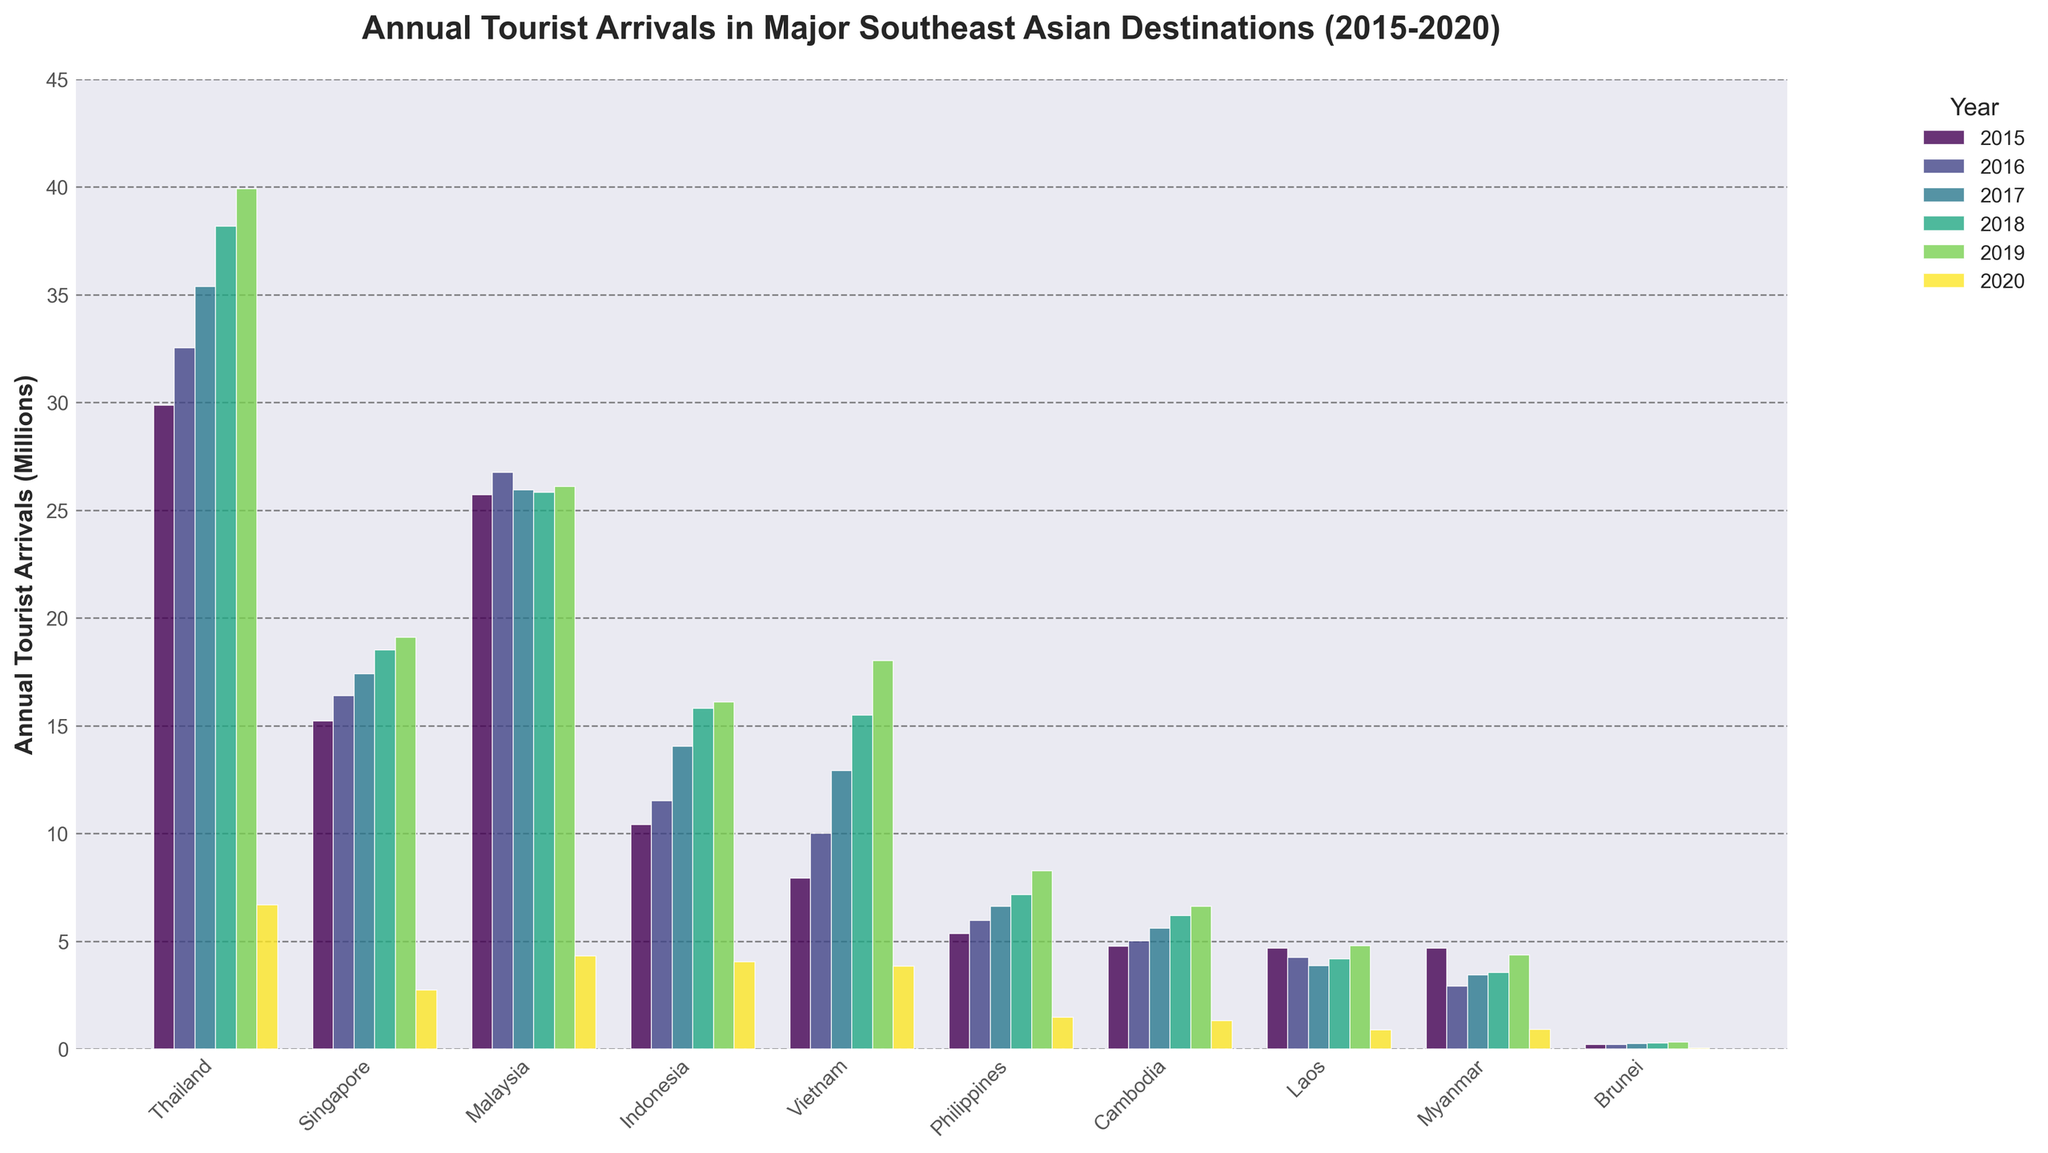Which country had the highest tourist arrivals in 2019? By looking at the heights of the bars for 2019, Thailand had the highest bar, indicating the highest tourist arrivals.
Answer: Thailand How many more tourists visited Thailand in 2018 compared to 2016? Subtract the number of tourist arrivals in 2016 from those in 2018 for Thailand (38.18 million - 32.53 million).
Answer: 5.65 million Which year had the lowest tourist arrivals for Malaysia? By comparing the heights of the bars for Malaysia across all years, 2020 had the lowest tourist arrivals.
Answer: 2020 Which country had a significant drop in tourist arrivals from 2019 to 2020? By comparing the heights of the bars between 2019 and 2020, Thailand shows a drastic drop from 39.92 million to 6.70 million.
Answer: Thailand What is the total number of tourist arrivals for Vietnam from 2015 to 2020? Add the number of tourist arrivals for each year for Vietnam (7.94 + 10.01 + 12.92 + 15.50 + 18.01 + 3.84).
Answer: 68.22 million Which country had more tourist arrivals in 2017, Indonesia or Vietnam? Compare the heights of the bars for Indonesia and Vietnam in 2017. Vietnam had a higher bar.
Answer: Vietnam What was the average tourist arrivals for Singapore from 2015 to 2020? Add the number of tourist arrivals for each year for Singapore and divide by the number of years (15.23 + 16.40 + 17.40 + 18.51 + 19.11 + 2.74) / 6.
Answer: 14.23 million In which year did the Philippines see its highest tourist arrivals? By comparing the bar heights for the Philippines across all years, 2019 had the highest bar indicating peak tourist arrivals.
Answer: 2019 How did the tourist arrivals in Cambodia change from 2016 to 2019? Subtract the number of tourist arrivals in 2016 from those in 2019 for Cambodia (6.61 million - 5.01 million).
Answer: 1.60 million What is the trend of tourist arrivals in Laos from 2015 to 2020? Observe the bar height changes over the years for Laos. The trend shows a decrease from 2015 to 2017, a slight rise in 2018, again slightly increasing in 2019, and then a steep drop in 2020.
Answer: Decreasing then slightly increasing before a steep drop 